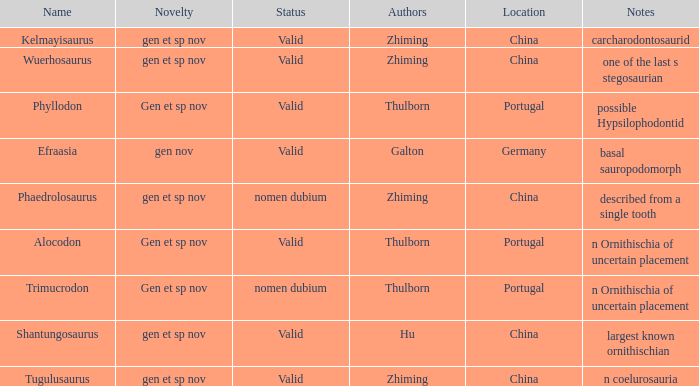What is the Name of the dinosaur that was discovered in the Location, China, and whose Notes are, "described from a single tooth"? Phaedrolosaurus. 